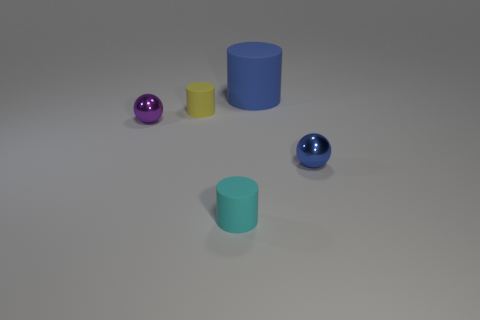Add 5 cyan rubber cylinders. How many objects exist? 10 Subtract all spheres. How many objects are left? 3 Subtract 0 gray balls. How many objects are left? 5 Subtract all large blue cylinders. Subtract all small metallic spheres. How many objects are left? 2 Add 4 small yellow rubber cylinders. How many small yellow rubber cylinders are left? 5 Add 2 small green cylinders. How many small green cylinders exist? 2 